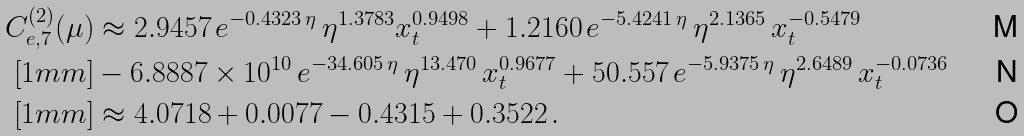<formula> <loc_0><loc_0><loc_500><loc_500>C _ { e , 7 } ^ { ( 2 ) } ( \mu ) & \approx 2 . 9 4 5 7 \, e ^ { - 0 . 4 3 2 3 \, \eta } \, \eta ^ { 1 . 3 7 8 3 } x _ { t } ^ { 0 . 9 4 9 8 } + 1 . 2 1 6 0 \, e ^ { - 5 . 4 2 4 1 \, \eta } \, \eta ^ { 2 . 1 3 6 5 } \, x _ { t } ^ { - 0 . 5 4 7 9 } \\ [ 1 m m ] & - 6 . 8 8 8 7 \times 1 0 ^ { 1 0 } \, e ^ { - 3 4 . 6 0 5 \, \eta } \, \eta ^ { 1 3 . 4 7 0 } \, x _ { t } ^ { 0 . 9 6 7 7 } + 5 0 . 5 5 7 \, e ^ { - 5 . 9 3 7 5 \, \eta } \, \eta ^ { 2 . 6 4 8 9 } \, x _ { t } ^ { - 0 . 0 7 3 6 } \\ [ 1 m m ] & \approx 4 . 0 7 1 8 + 0 . 0 0 7 7 - 0 . 4 3 1 5 + 0 . 3 5 2 2 \, .</formula> 